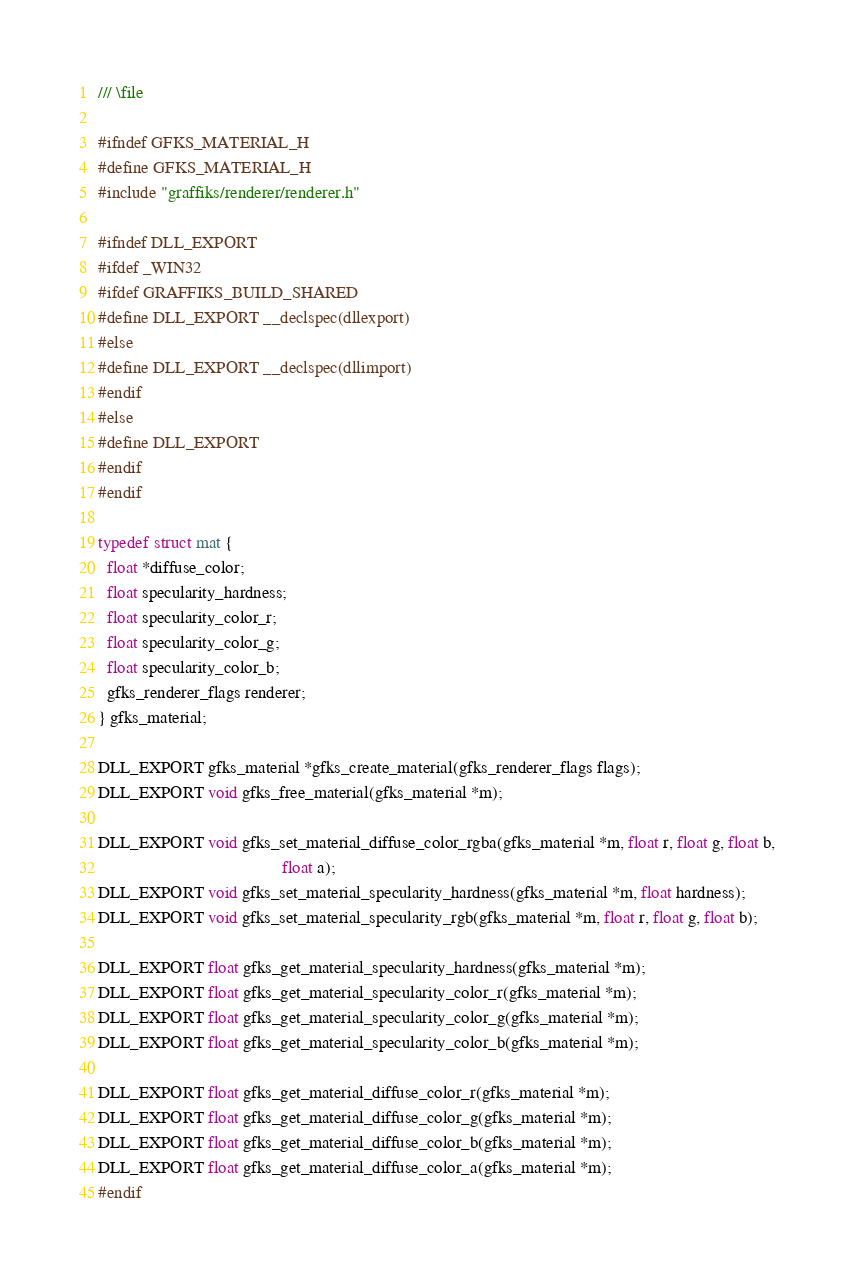Convert code to text. <code><loc_0><loc_0><loc_500><loc_500><_C_>/// \file

#ifndef GFKS_MATERIAL_H
#define GFKS_MATERIAL_H
#include "graffiks/renderer/renderer.h"

#ifndef DLL_EXPORT
#ifdef _WIN32
#ifdef GRAFFIKS_BUILD_SHARED
#define DLL_EXPORT __declspec(dllexport)
#else
#define DLL_EXPORT __declspec(dllimport)
#endif
#else
#define DLL_EXPORT
#endif
#endif

typedef struct mat {
  float *diffuse_color;
  float specularity_hardness;
  float specularity_color_r;
  float specularity_color_g;
  float specularity_color_b;
  gfks_renderer_flags renderer;
} gfks_material;

DLL_EXPORT gfks_material *gfks_create_material(gfks_renderer_flags flags);
DLL_EXPORT void gfks_free_material(gfks_material *m);

DLL_EXPORT void gfks_set_material_diffuse_color_rgba(gfks_material *m, float r, float g, float b,
                                          float a);
DLL_EXPORT void gfks_set_material_specularity_hardness(gfks_material *m, float hardness);
DLL_EXPORT void gfks_set_material_specularity_rgb(gfks_material *m, float r, float g, float b);

DLL_EXPORT float gfks_get_material_specularity_hardness(gfks_material *m);
DLL_EXPORT float gfks_get_material_specularity_color_r(gfks_material *m);
DLL_EXPORT float gfks_get_material_specularity_color_g(gfks_material *m);
DLL_EXPORT float gfks_get_material_specularity_color_b(gfks_material *m);

DLL_EXPORT float gfks_get_material_diffuse_color_r(gfks_material *m);
DLL_EXPORT float gfks_get_material_diffuse_color_g(gfks_material *m);
DLL_EXPORT float gfks_get_material_diffuse_color_b(gfks_material *m);
DLL_EXPORT float gfks_get_material_diffuse_color_a(gfks_material *m);
#endif
</code> 